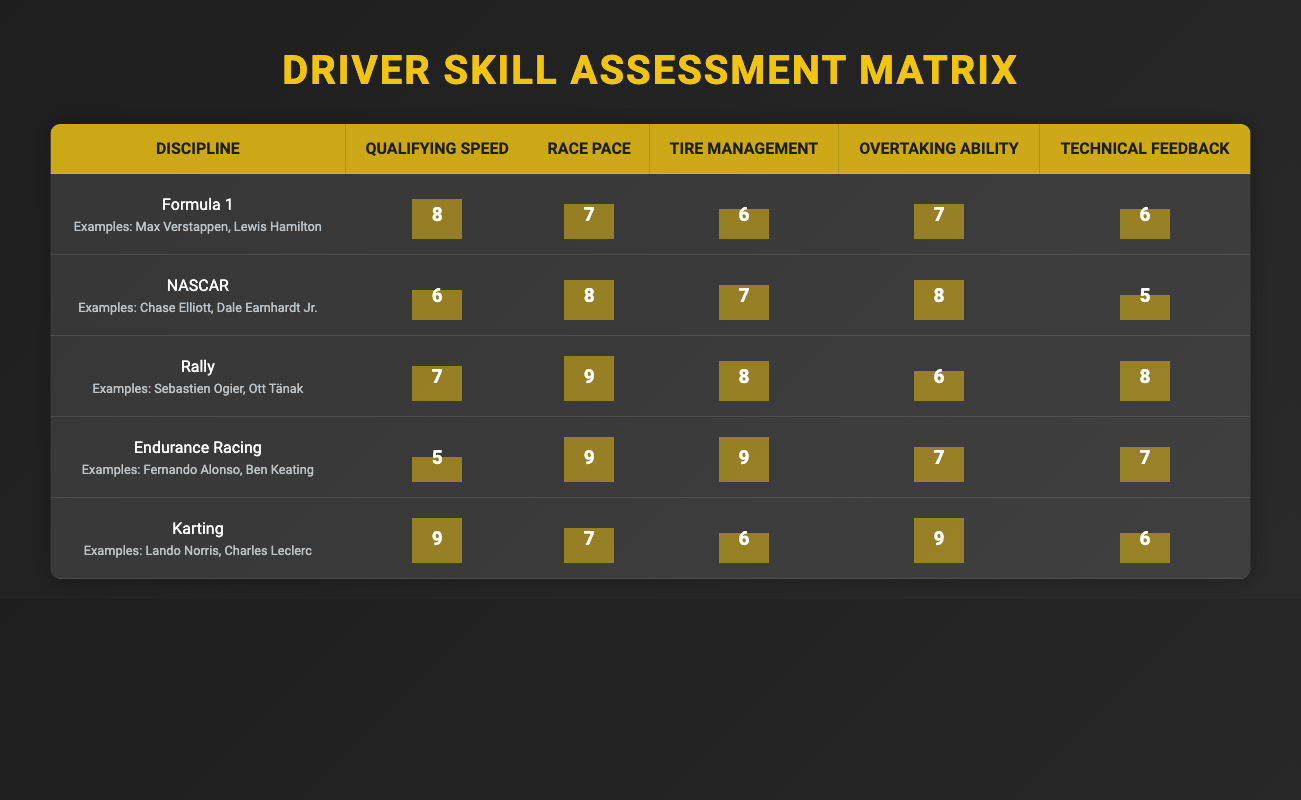What is the scoring for Qualifying Speed in Rally? The table indicates that in the Rally category, the scoring for Qualifying Speed is 7.
Answer: 7 Which racing discipline has the highest score for Tire Management? By reviewing the Tire Management scores across all disciplines, we see that both Rally and Endurance Racing have the highest score of 9.
Answer: Endurance Racing and Rally What is the average score for Race Pace across all disciplines? The Race Pace scores are 7 (F1), 8 (NASCAR), 9 (Rally), 9 (Endurance Racing), and 7 (Karting). Summing these gives 40, and dividing by 5 disciplines gives an average score of 8.
Answer: 8 Is the Overtaking Ability score for NASCAR greater than that for Formula 1? The Overtaking Ability score for NASCAR is 8, while for Formula 1 it is 7. Therefore, NASCAR has a higher score.
Answer: Yes Which discipline has lower Technical Feedback: NASCAR or Endurance Racing? NASCAR has a Technical Feedback score of 5, while Endurance Racing has a score of 7. Thus, NASCAR has lower Technical Feedback.
Answer: NASCAR What is the difference in Qualifying Speed scores between Karting and Endurance Racing? The Qualifying Speed score for Karting is 9, while for Endurance Racing it is 5. The difference is calculated as 9 - 5 = 4.
Answer: 4 Which racing discipline has the lowest score in Qualifying Speed? By looking at the Qualifying Speed scores, Endurance Racing with a score of 5 is the discipline with the lowest score.
Answer: Endurance Racing Do any of the racing disciplines share the same score for Overtaking Ability? Yes, both Formula 1 and Endurance Racing have an Overtaking Ability score of 7.
Answer: Yes What is the overall highest skill area across all disciplines? The highest individual scores across all skill areas are in Qualifying Speed for Karting and Race Pace for Rally and Endurance Racing, which are all 9. However, the highest singular discipline in terms of skill area is not just one area but varies.
Answer: Varies among skills 9 in Karting, Rally, and Endurance Racing 